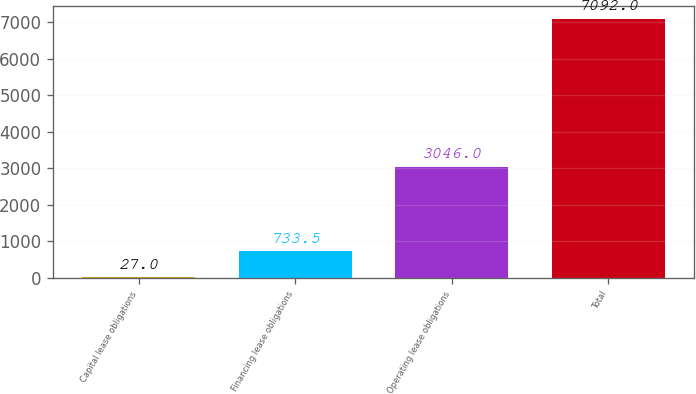Convert chart to OTSL. <chart><loc_0><loc_0><loc_500><loc_500><bar_chart><fcel>Capital lease obligations<fcel>Financing lease obligations<fcel>Operating lease obligations<fcel>Total<nl><fcel>27<fcel>733.5<fcel>3046<fcel>7092<nl></chart> 